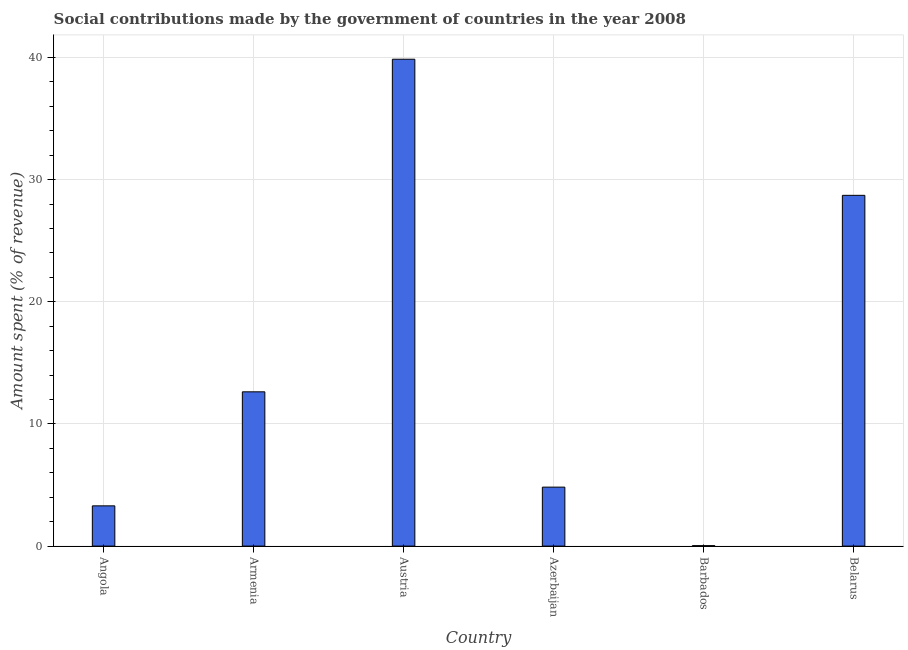Does the graph contain any zero values?
Give a very brief answer. No. Does the graph contain grids?
Your answer should be very brief. Yes. What is the title of the graph?
Your answer should be very brief. Social contributions made by the government of countries in the year 2008. What is the label or title of the Y-axis?
Offer a very short reply. Amount spent (% of revenue). What is the amount spent in making social contributions in Azerbaijan?
Give a very brief answer. 4.83. Across all countries, what is the maximum amount spent in making social contributions?
Give a very brief answer. 39.86. Across all countries, what is the minimum amount spent in making social contributions?
Provide a succinct answer. 0.04. In which country was the amount spent in making social contributions minimum?
Your answer should be very brief. Barbados. What is the sum of the amount spent in making social contributions?
Provide a succinct answer. 89.37. What is the difference between the amount spent in making social contributions in Angola and Azerbaijan?
Offer a terse response. -1.53. What is the average amount spent in making social contributions per country?
Keep it short and to the point. 14.89. What is the median amount spent in making social contributions?
Make the answer very short. 8.73. What is the ratio of the amount spent in making social contributions in Angola to that in Belarus?
Offer a very short reply. 0.12. What is the difference between the highest and the second highest amount spent in making social contributions?
Your answer should be compact. 11.14. Is the sum of the amount spent in making social contributions in Austria and Belarus greater than the maximum amount spent in making social contributions across all countries?
Give a very brief answer. Yes. What is the difference between the highest and the lowest amount spent in making social contributions?
Provide a succinct answer. 39.83. In how many countries, is the amount spent in making social contributions greater than the average amount spent in making social contributions taken over all countries?
Make the answer very short. 2. How many bars are there?
Ensure brevity in your answer.  6. Are all the bars in the graph horizontal?
Your answer should be compact. No. How many countries are there in the graph?
Keep it short and to the point. 6. What is the difference between two consecutive major ticks on the Y-axis?
Ensure brevity in your answer.  10. Are the values on the major ticks of Y-axis written in scientific E-notation?
Provide a succinct answer. No. What is the Amount spent (% of revenue) in Angola?
Your answer should be compact. 3.29. What is the Amount spent (% of revenue) in Armenia?
Offer a very short reply. 12.63. What is the Amount spent (% of revenue) in Austria?
Provide a short and direct response. 39.86. What is the Amount spent (% of revenue) in Azerbaijan?
Your answer should be compact. 4.83. What is the Amount spent (% of revenue) in Barbados?
Your answer should be very brief. 0.04. What is the Amount spent (% of revenue) of Belarus?
Offer a very short reply. 28.72. What is the difference between the Amount spent (% of revenue) in Angola and Armenia?
Provide a succinct answer. -9.34. What is the difference between the Amount spent (% of revenue) in Angola and Austria?
Your response must be concise. -36.57. What is the difference between the Amount spent (% of revenue) in Angola and Azerbaijan?
Your answer should be compact. -1.53. What is the difference between the Amount spent (% of revenue) in Angola and Barbados?
Offer a terse response. 3.26. What is the difference between the Amount spent (% of revenue) in Angola and Belarus?
Provide a succinct answer. -25.42. What is the difference between the Amount spent (% of revenue) in Armenia and Austria?
Provide a short and direct response. -27.23. What is the difference between the Amount spent (% of revenue) in Armenia and Azerbaijan?
Keep it short and to the point. 7.8. What is the difference between the Amount spent (% of revenue) in Armenia and Barbados?
Provide a short and direct response. 12.6. What is the difference between the Amount spent (% of revenue) in Armenia and Belarus?
Give a very brief answer. -16.09. What is the difference between the Amount spent (% of revenue) in Austria and Azerbaijan?
Offer a terse response. 35.03. What is the difference between the Amount spent (% of revenue) in Austria and Barbados?
Offer a very short reply. 39.83. What is the difference between the Amount spent (% of revenue) in Austria and Belarus?
Offer a very short reply. 11.14. What is the difference between the Amount spent (% of revenue) in Azerbaijan and Barbados?
Give a very brief answer. 4.79. What is the difference between the Amount spent (% of revenue) in Azerbaijan and Belarus?
Provide a short and direct response. -23.89. What is the difference between the Amount spent (% of revenue) in Barbados and Belarus?
Ensure brevity in your answer.  -28.68. What is the ratio of the Amount spent (% of revenue) in Angola to that in Armenia?
Offer a very short reply. 0.26. What is the ratio of the Amount spent (% of revenue) in Angola to that in Austria?
Ensure brevity in your answer.  0.08. What is the ratio of the Amount spent (% of revenue) in Angola to that in Azerbaijan?
Provide a succinct answer. 0.68. What is the ratio of the Amount spent (% of revenue) in Angola to that in Barbados?
Your response must be concise. 91.07. What is the ratio of the Amount spent (% of revenue) in Angola to that in Belarus?
Provide a succinct answer. 0.12. What is the ratio of the Amount spent (% of revenue) in Armenia to that in Austria?
Your response must be concise. 0.32. What is the ratio of the Amount spent (% of revenue) in Armenia to that in Azerbaijan?
Provide a succinct answer. 2.62. What is the ratio of the Amount spent (% of revenue) in Armenia to that in Barbados?
Provide a succinct answer. 349.12. What is the ratio of the Amount spent (% of revenue) in Armenia to that in Belarus?
Ensure brevity in your answer.  0.44. What is the ratio of the Amount spent (% of revenue) in Austria to that in Azerbaijan?
Offer a very short reply. 8.26. What is the ratio of the Amount spent (% of revenue) in Austria to that in Barbados?
Offer a very short reply. 1101.75. What is the ratio of the Amount spent (% of revenue) in Austria to that in Belarus?
Provide a short and direct response. 1.39. What is the ratio of the Amount spent (% of revenue) in Azerbaijan to that in Barbados?
Offer a terse response. 133.43. What is the ratio of the Amount spent (% of revenue) in Azerbaijan to that in Belarus?
Make the answer very short. 0.17. What is the ratio of the Amount spent (% of revenue) in Barbados to that in Belarus?
Ensure brevity in your answer.  0. 